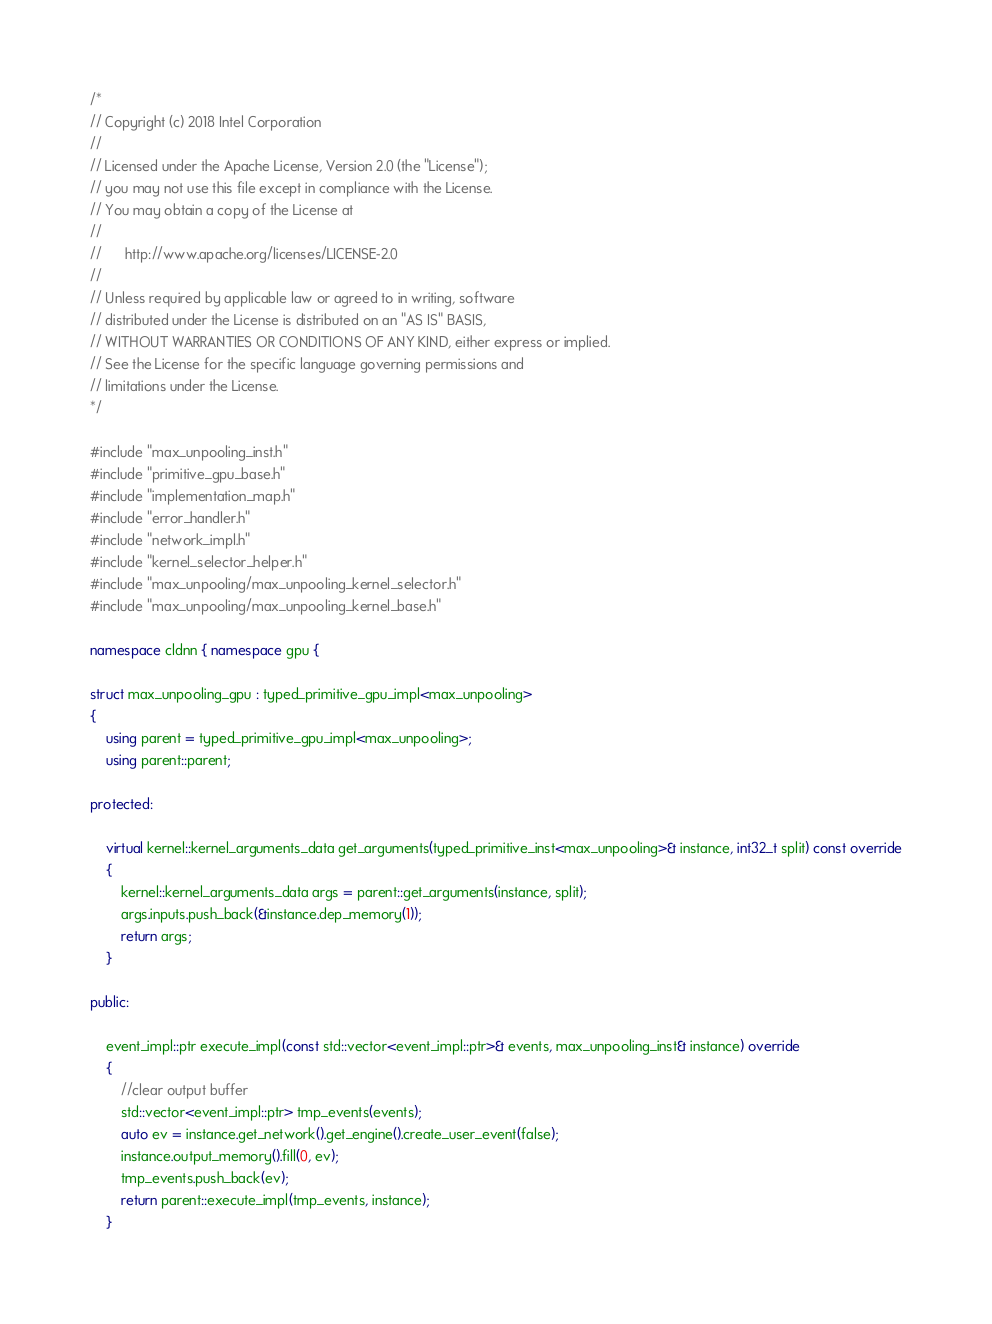<code> <loc_0><loc_0><loc_500><loc_500><_C++_>/*
// Copyright (c) 2018 Intel Corporation
//
// Licensed under the Apache License, Version 2.0 (the "License");
// you may not use this file except in compliance with the License.
// You may obtain a copy of the License at
//
//      http://www.apache.org/licenses/LICENSE-2.0
//
// Unless required by applicable law or agreed to in writing, software
// distributed under the License is distributed on an "AS IS" BASIS,
// WITHOUT WARRANTIES OR CONDITIONS OF ANY KIND, either express or implied.
// See the License for the specific language governing permissions and
// limitations under the License.
*/

#include "max_unpooling_inst.h"
#include "primitive_gpu_base.h"
#include "implementation_map.h"
#include "error_handler.h"
#include "network_impl.h"
#include "kernel_selector_helper.h"
#include "max_unpooling/max_unpooling_kernel_selector.h"
#include "max_unpooling/max_unpooling_kernel_base.h"

namespace cldnn { namespace gpu {

struct max_unpooling_gpu : typed_primitive_gpu_impl<max_unpooling>
{
    using parent = typed_primitive_gpu_impl<max_unpooling>;
    using parent::parent;

protected:

    virtual kernel::kernel_arguments_data get_arguments(typed_primitive_inst<max_unpooling>& instance, int32_t split) const override
    {
        kernel::kernel_arguments_data args = parent::get_arguments(instance, split);
        args.inputs.push_back(&instance.dep_memory(1));
        return args;
    }

public:

    event_impl::ptr execute_impl(const std::vector<event_impl::ptr>& events, max_unpooling_inst& instance) override
    {
        //clear output buffer
        std::vector<event_impl::ptr> tmp_events(events);
        auto ev = instance.get_network().get_engine().create_user_event(false);
        instance.output_memory().fill(0, ev);
        tmp_events.push_back(ev);
        return parent::execute_impl(tmp_events, instance);
    }
</code> 